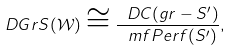Convert formula to latex. <formula><loc_0><loc_0><loc_500><loc_500>D G r S ( \mathcal { W } ) \cong \frac { \ D C ( g r - S ^ { \prime } ) } { \ m f { P e r f } ( S ^ { \prime } ) } ,</formula> 